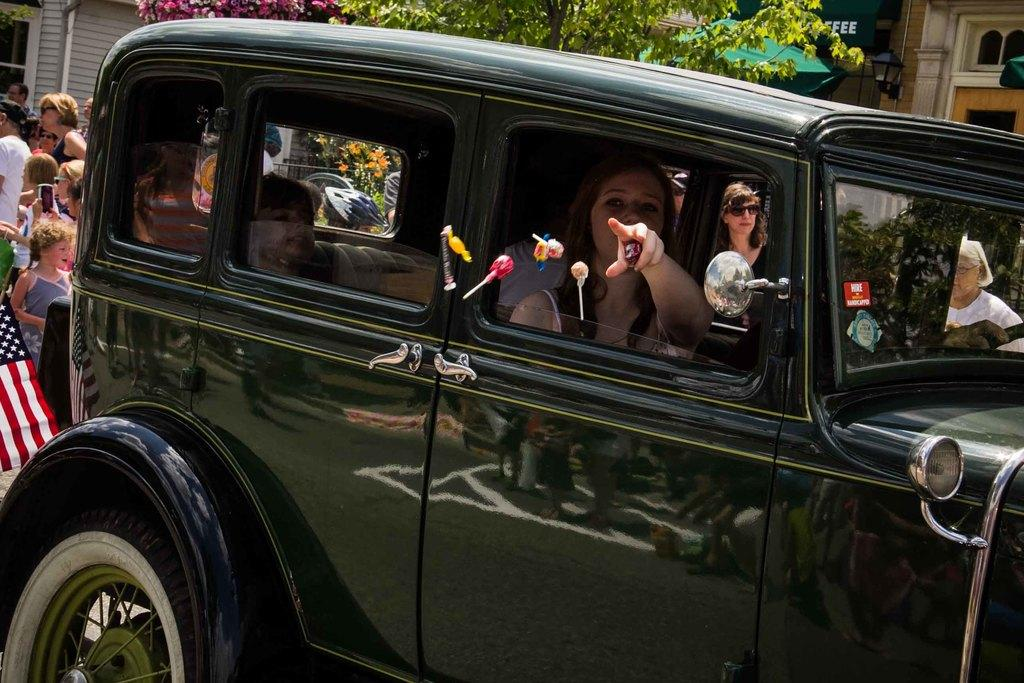What is the main subject of the picture? The main subject of the picture is a car. Who is inside the car? A lady is present inside the car. What is happening outside the car? There are many people walking in the image. What can be seen in the background of the picture? There are trees, buildings, and a flag in the image. What type of store is the lady operating in the image? There is no store present in the image, and the lady is not operating anything. What surprise event is happening in the image? There is no surprise event happening in the image; it simply shows a car, a lady, people walking, trees, buildings, and a flag. 